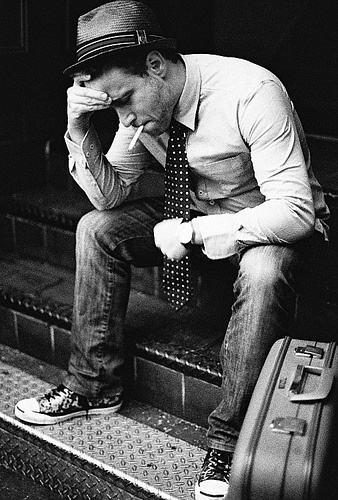Describe the objects in this image and their specific colors. I can see people in black, lightgray, gray, and darkgray tones, suitcase in black, darkgray, gray, and lightgray tones, and tie in black, gray, white, and darkgray tones in this image. 